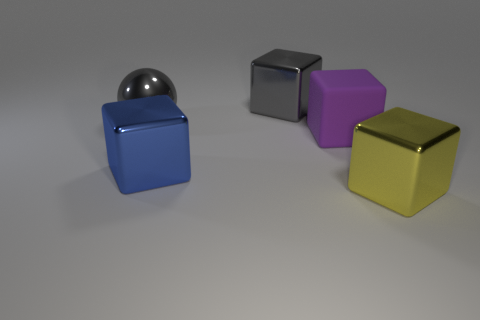Add 4 matte objects. How many objects exist? 9 Subtract all blocks. How many objects are left? 1 Add 2 green balls. How many green balls exist? 2 Subtract 0 green spheres. How many objects are left? 5 Subtract all big purple matte blocks. Subtract all gray balls. How many objects are left? 3 Add 2 purple matte things. How many purple matte things are left? 3 